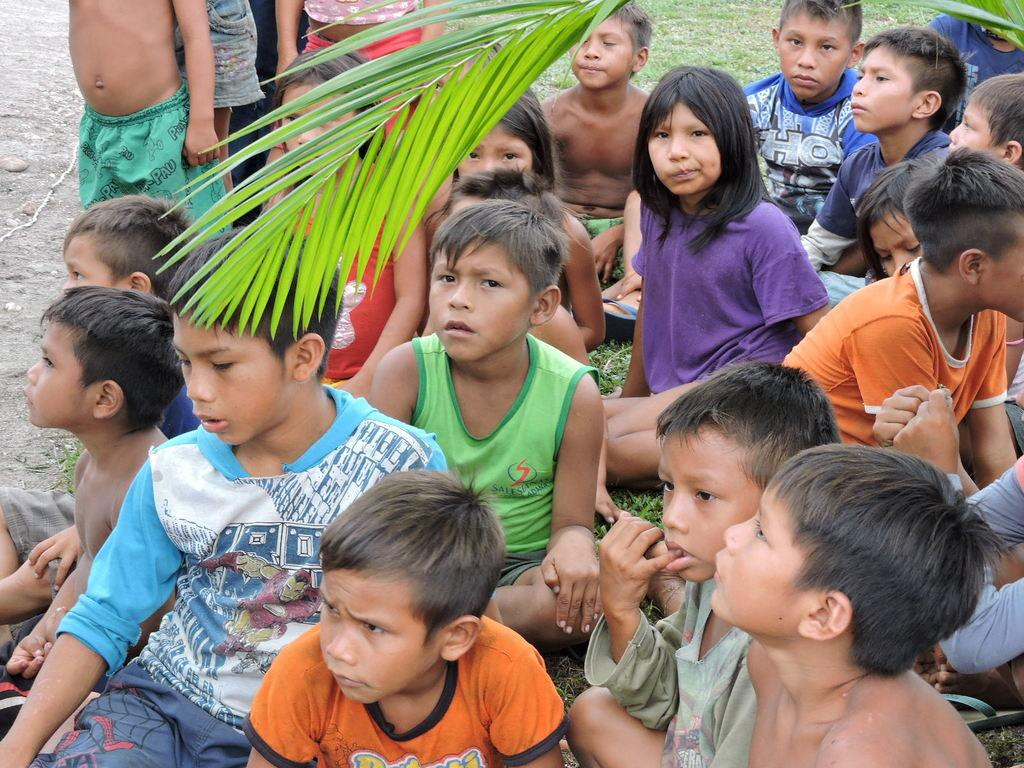What is the main subject of the image? The main subject of the image is a group of kids. What are the kids doing in the image? The kids are sitting on the ground. What type of vegetation can be seen in the image? There are green leaves visible at the top of the image. How many jellyfish are swimming in the air above the kids in the image? There are no jellyfish present in the image, as jellyfish are marine creatures and not found in the air. 